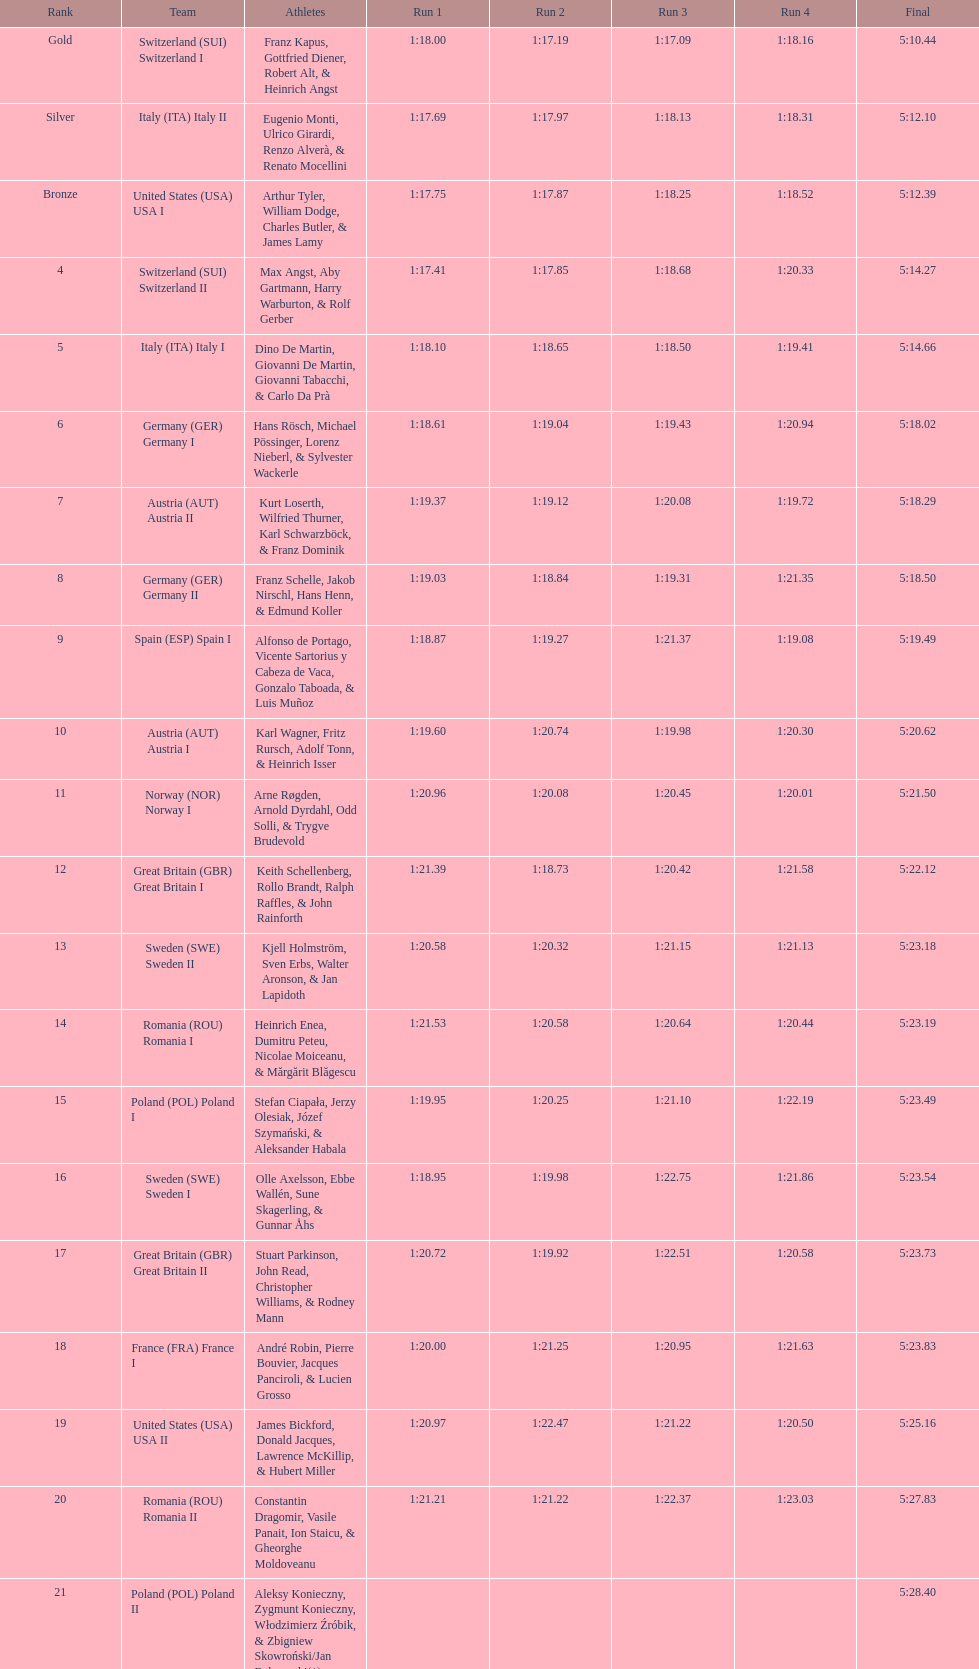Write the full table. {'header': ['Rank', 'Team', 'Athletes', 'Run 1', 'Run 2', 'Run 3', 'Run 4', 'Final'], 'rows': [['Gold', 'Switzerland\xa0(SUI) Switzerland I', 'Franz Kapus, Gottfried Diener, Robert Alt, & Heinrich Angst', '1:18.00', '1:17.19', '1:17.09', '1:18.16', '5:10.44'], ['Silver', 'Italy\xa0(ITA) Italy II', 'Eugenio Monti, Ulrico Girardi, Renzo Alverà, & Renato Mocellini', '1:17.69', '1:17.97', '1:18.13', '1:18.31', '5:12.10'], ['Bronze', 'United States\xa0(USA) USA I', 'Arthur Tyler, William Dodge, Charles Butler, & James Lamy', '1:17.75', '1:17.87', '1:18.25', '1:18.52', '5:12.39'], ['4', 'Switzerland\xa0(SUI) Switzerland II', 'Max Angst, Aby Gartmann, Harry Warburton, & Rolf Gerber', '1:17.41', '1:17.85', '1:18.68', '1:20.33', '5:14.27'], ['5', 'Italy\xa0(ITA) Italy I', 'Dino De Martin, Giovanni De Martin, Giovanni Tabacchi, & Carlo Da Prà', '1:18.10', '1:18.65', '1:18.50', '1:19.41', '5:14.66'], ['6', 'Germany\xa0(GER) Germany I', 'Hans Rösch, Michael Pössinger, Lorenz Nieberl, & Sylvester Wackerle', '1:18.61', '1:19.04', '1:19.43', '1:20.94', '5:18.02'], ['7', 'Austria\xa0(AUT) Austria II', 'Kurt Loserth, Wilfried Thurner, Karl Schwarzböck, & Franz Dominik', '1:19.37', '1:19.12', '1:20.08', '1:19.72', '5:18.29'], ['8', 'Germany\xa0(GER) Germany II', 'Franz Schelle, Jakob Nirschl, Hans Henn, & Edmund Koller', '1:19.03', '1:18.84', '1:19.31', '1:21.35', '5:18.50'], ['9', 'Spain\xa0(ESP) Spain I', 'Alfonso de Portago, Vicente Sartorius y Cabeza de Vaca, Gonzalo Taboada, & Luis Muñoz', '1:18.87', '1:19.27', '1:21.37', '1:19.08', '5:19.49'], ['10', 'Austria\xa0(AUT) Austria I', 'Karl Wagner, Fritz Rursch, Adolf Tonn, & Heinrich Isser', '1:19.60', '1:20.74', '1:19.98', '1:20.30', '5:20.62'], ['11', 'Norway\xa0(NOR) Norway I', 'Arne Røgden, Arnold Dyrdahl, Odd Solli, & Trygve Brudevold', '1:20.96', '1:20.08', '1:20.45', '1:20.01', '5:21.50'], ['12', 'Great Britain\xa0(GBR) Great Britain I', 'Keith Schellenberg, Rollo Brandt, Ralph Raffles, & John Rainforth', '1:21.39', '1:18.73', '1:20.42', '1:21.58', '5:22.12'], ['13', 'Sweden\xa0(SWE) Sweden II', 'Kjell Holmström, Sven Erbs, Walter Aronson, & Jan Lapidoth', '1:20.58', '1:20.32', '1:21.15', '1:21.13', '5:23.18'], ['14', 'Romania\xa0(ROU) Romania I', 'Heinrich Enea, Dumitru Peteu, Nicolae Moiceanu, & Mărgărit Blăgescu', '1:21.53', '1:20.58', '1:20.64', '1:20.44', '5:23.19'], ['15', 'Poland\xa0(POL) Poland I', 'Stefan Ciapała, Jerzy Olesiak, Józef Szymański, & Aleksander Habala', '1:19.95', '1:20.25', '1:21.10', '1:22.19', '5:23.49'], ['16', 'Sweden\xa0(SWE) Sweden I', 'Olle Axelsson, Ebbe Wallén, Sune Skagerling, & Gunnar Åhs', '1:18.95', '1:19.98', '1:22.75', '1:21.86', '5:23.54'], ['17', 'Great Britain\xa0(GBR) Great Britain II', 'Stuart Parkinson, John Read, Christopher Williams, & Rodney Mann', '1:20.72', '1:19.92', '1:22.51', '1:20.58', '5:23.73'], ['18', 'France\xa0(FRA) France I', 'André Robin, Pierre Bouvier, Jacques Panciroli, & Lucien Grosso', '1:20.00', '1:21.25', '1:20.95', '1:21.63', '5:23.83'], ['19', 'United States\xa0(USA) USA II', 'James Bickford, Donald Jacques, Lawrence McKillip, & Hubert Miller', '1:20.97', '1:22.47', '1:21.22', '1:20.50', '5:25.16'], ['20', 'Romania\xa0(ROU) Romania II', 'Constantin Dragomir, Vasile Panait, Ion Staicu, & Gheorghe Moldoveanu', '1:21.21', '1:21.22', '1:22.37', '1:23.03', '5:27.83'], ['21', 'Poland\xa0(POL) Poland II', 'Aleksy Konieczny, Zygmunt Konieczny, Włodzimierz Źróbik, & Zbigniew Skowroński/Jan Dąbrowski(*)', '', '', '', '', '5:28.40']]} Which team scored the highest number of runs? Switzerland. 